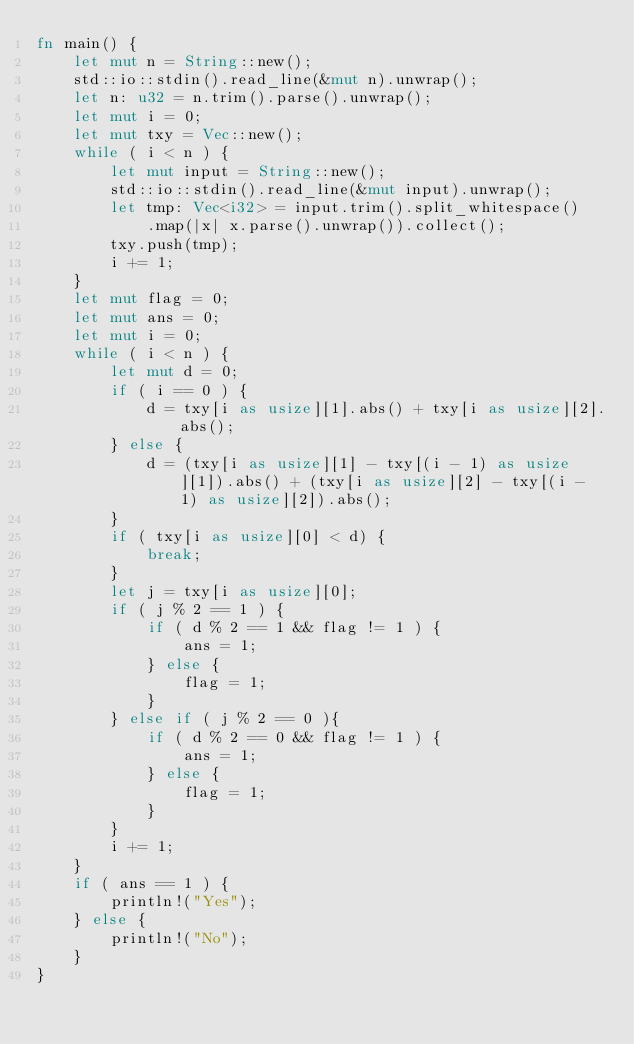Convert code to text. <code><loc_0><loc_0><loc_500><loc_500><_Rust_>fn main() {
    let mut n = String::new();
    std::io::stdin().read_line(&mut n).unwrap();
    let n: u32 = n.trim().parse().unwrap();
    let mut i = 0;
    let mut txy = Vec::new();
    while ( i < n ) {
        let mut input = String::new();
        std::io::stdin().read_line(&mut input).unwrap();
        let tmp: Vec<i32> = input.trim().split_whitespace()
            .map(|x| x.parse().unwrap()).collect();
        txy.push(tmp);
        i += 1;
    }
    let mut flag = 0;
    let mut ans = 0;
    let mut i = 0;
    while ( i < n ) {
        let mut d = 0;
        if ( i == 0 ) {
            d = txy[i as usize][1].abs() + txy[i as usize][2].abs();
        } else {
            d = (txy[i as usize][1] - txy[(i - 1) as usize][1]).abs() + (txy[i as usize][2] - txy[(i - 1) as usize][2]).abs();
        }
        if ( txy[i as usize][0] < d) {
            break;
        }
        let j = txy[i as usize][0];
        if ( j % 2 == 1 ) {
            if ( d % 2 == 1 && flag != 1 ) {
                ans = 1;
            } else {
                flag = 1;
            }
        } else if ( j % 2 == 0 ){
            if ( d % 2 == 0 && flag != 1 ) {
                ans = 1;
            } else {
                flag = 1;
            }
        }
        i += 1;
    }
    if ( ans == 1 ) {
        println!("Yes");
    } else {
        println!("No");
    }
}</code> 